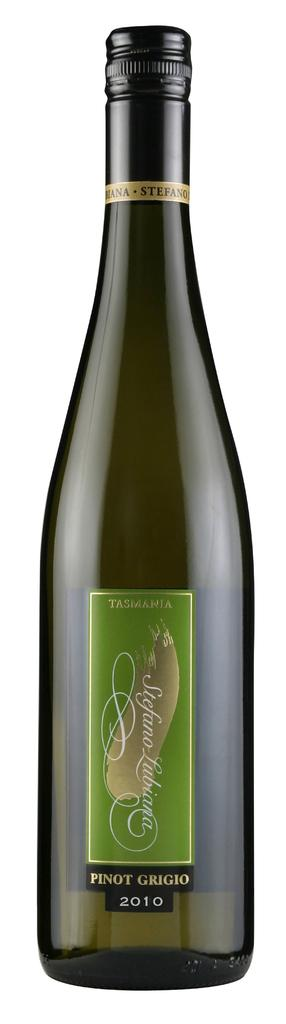<image>
Relay a brief, clear account of the picture shown. a pinot grigio that is on a large bottle 